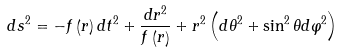<formula> <loc_0><loc_0><loc_500><loc_500>d s ^ { 2 } = - f \left ( r \right ) d t ^ { 2 } + \frac { d r ^ { 2 } } { f \left ( r \right ) } + r ^ { 2 } \left ( d \theta ^ { 2 } + \sin ^ { 2 } \theta d \varphi ^ { 2 } \right )</formula> 